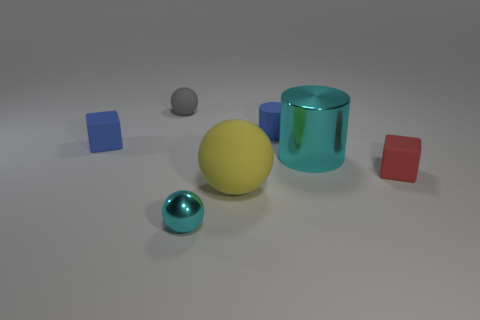Add 1 large cubes. How many objects exist? 8 Subtract all spheres. How many objects are left? 4 Add 7 large cyan cylinders. How many large cyan cylinders are left? 8 Add 1 gray balls. How many gray balls exist? 2 Subtract 0 purple spheres. How many objects are left? 7 Subtract all red rubber things. Subtract all tiny objects. How many objects are left? 1 